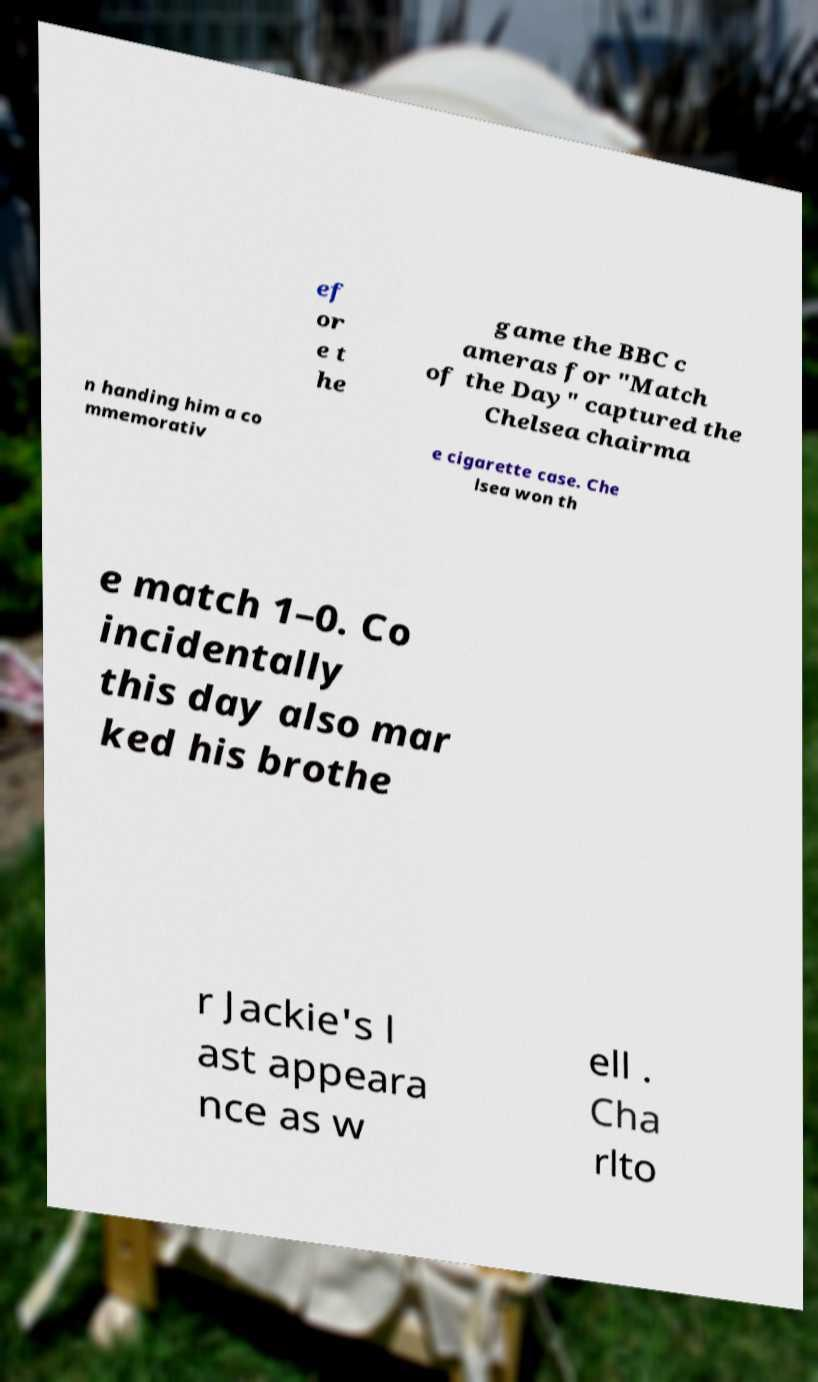Could you assist in decoding the text presented in this image and type it out clearly? ef or e t he game the BBC c ameras for "Match of the Day" captured the Chelsea chairma n handing him a co mmemorativ e cigarette case. Che lsea won th e match 1–0. Co incidentally this day also mar ked his brothe r Jackie's l ast appeara nce as w ell . Cha rlto 